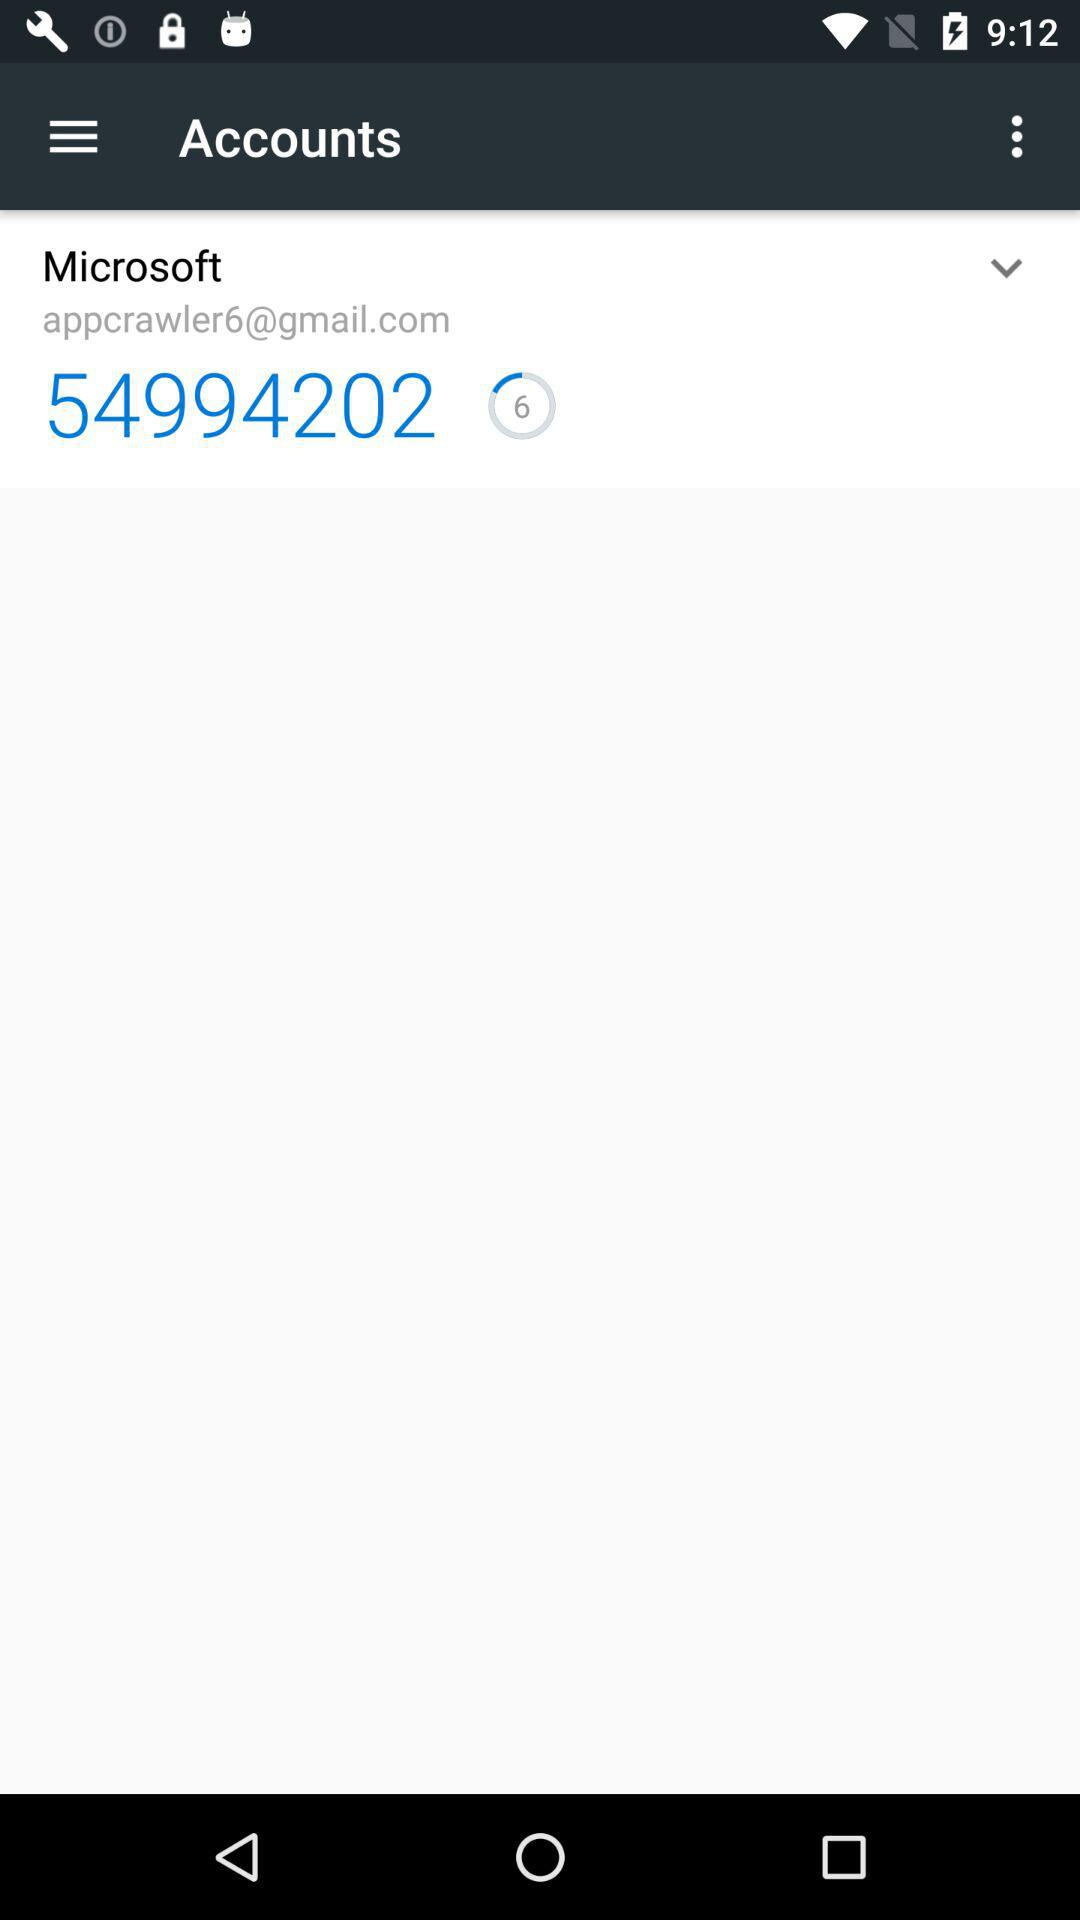What is the email address? The email address is appcrawler6@gmail.com. 